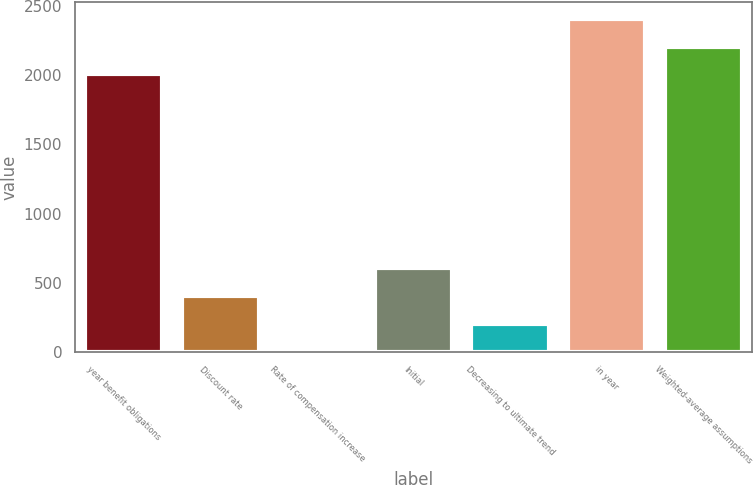<chart> <loc_0><loc_0><loc_500><loc_500><bar_chart><fcel>year benefit obligations<fcel>Discount rate<fcel>Rate of compensation increase<fcel>Initial<fcel>Decreasing to ultimate trend<fcel>in year<fcel>Weighted-average assumptions<nl><fcel>2006<fcel>405.21<fcel>3.75<fcel>605.93<fcel>204.48<fcel>2407.44<fcel>2206.72<nl></chart> 